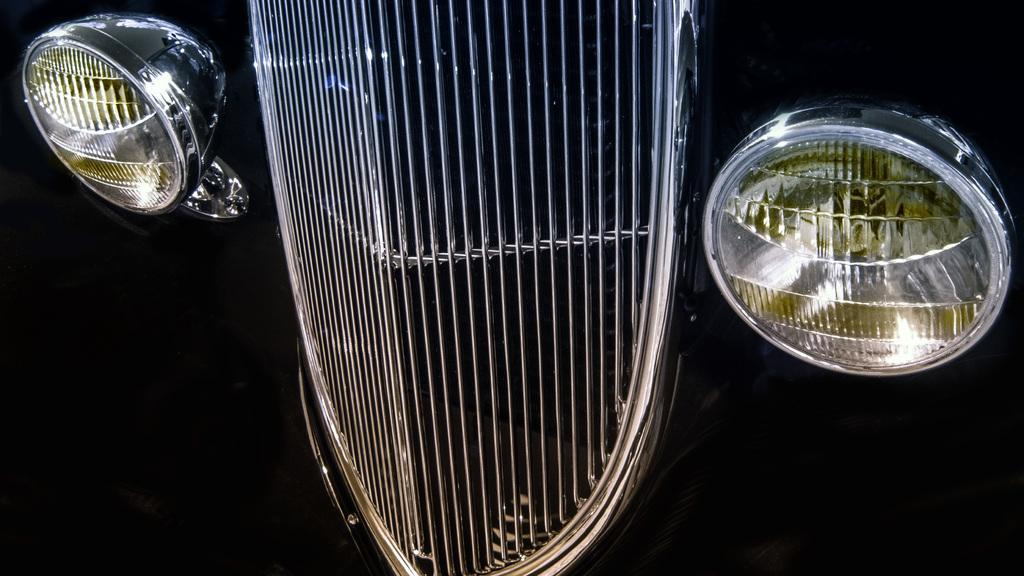In one or two sentences, can you explain what this image depicts? In this image we can see a front body of a vehicle, there are two light one on the left side and one on the right side. In the background there is black. 